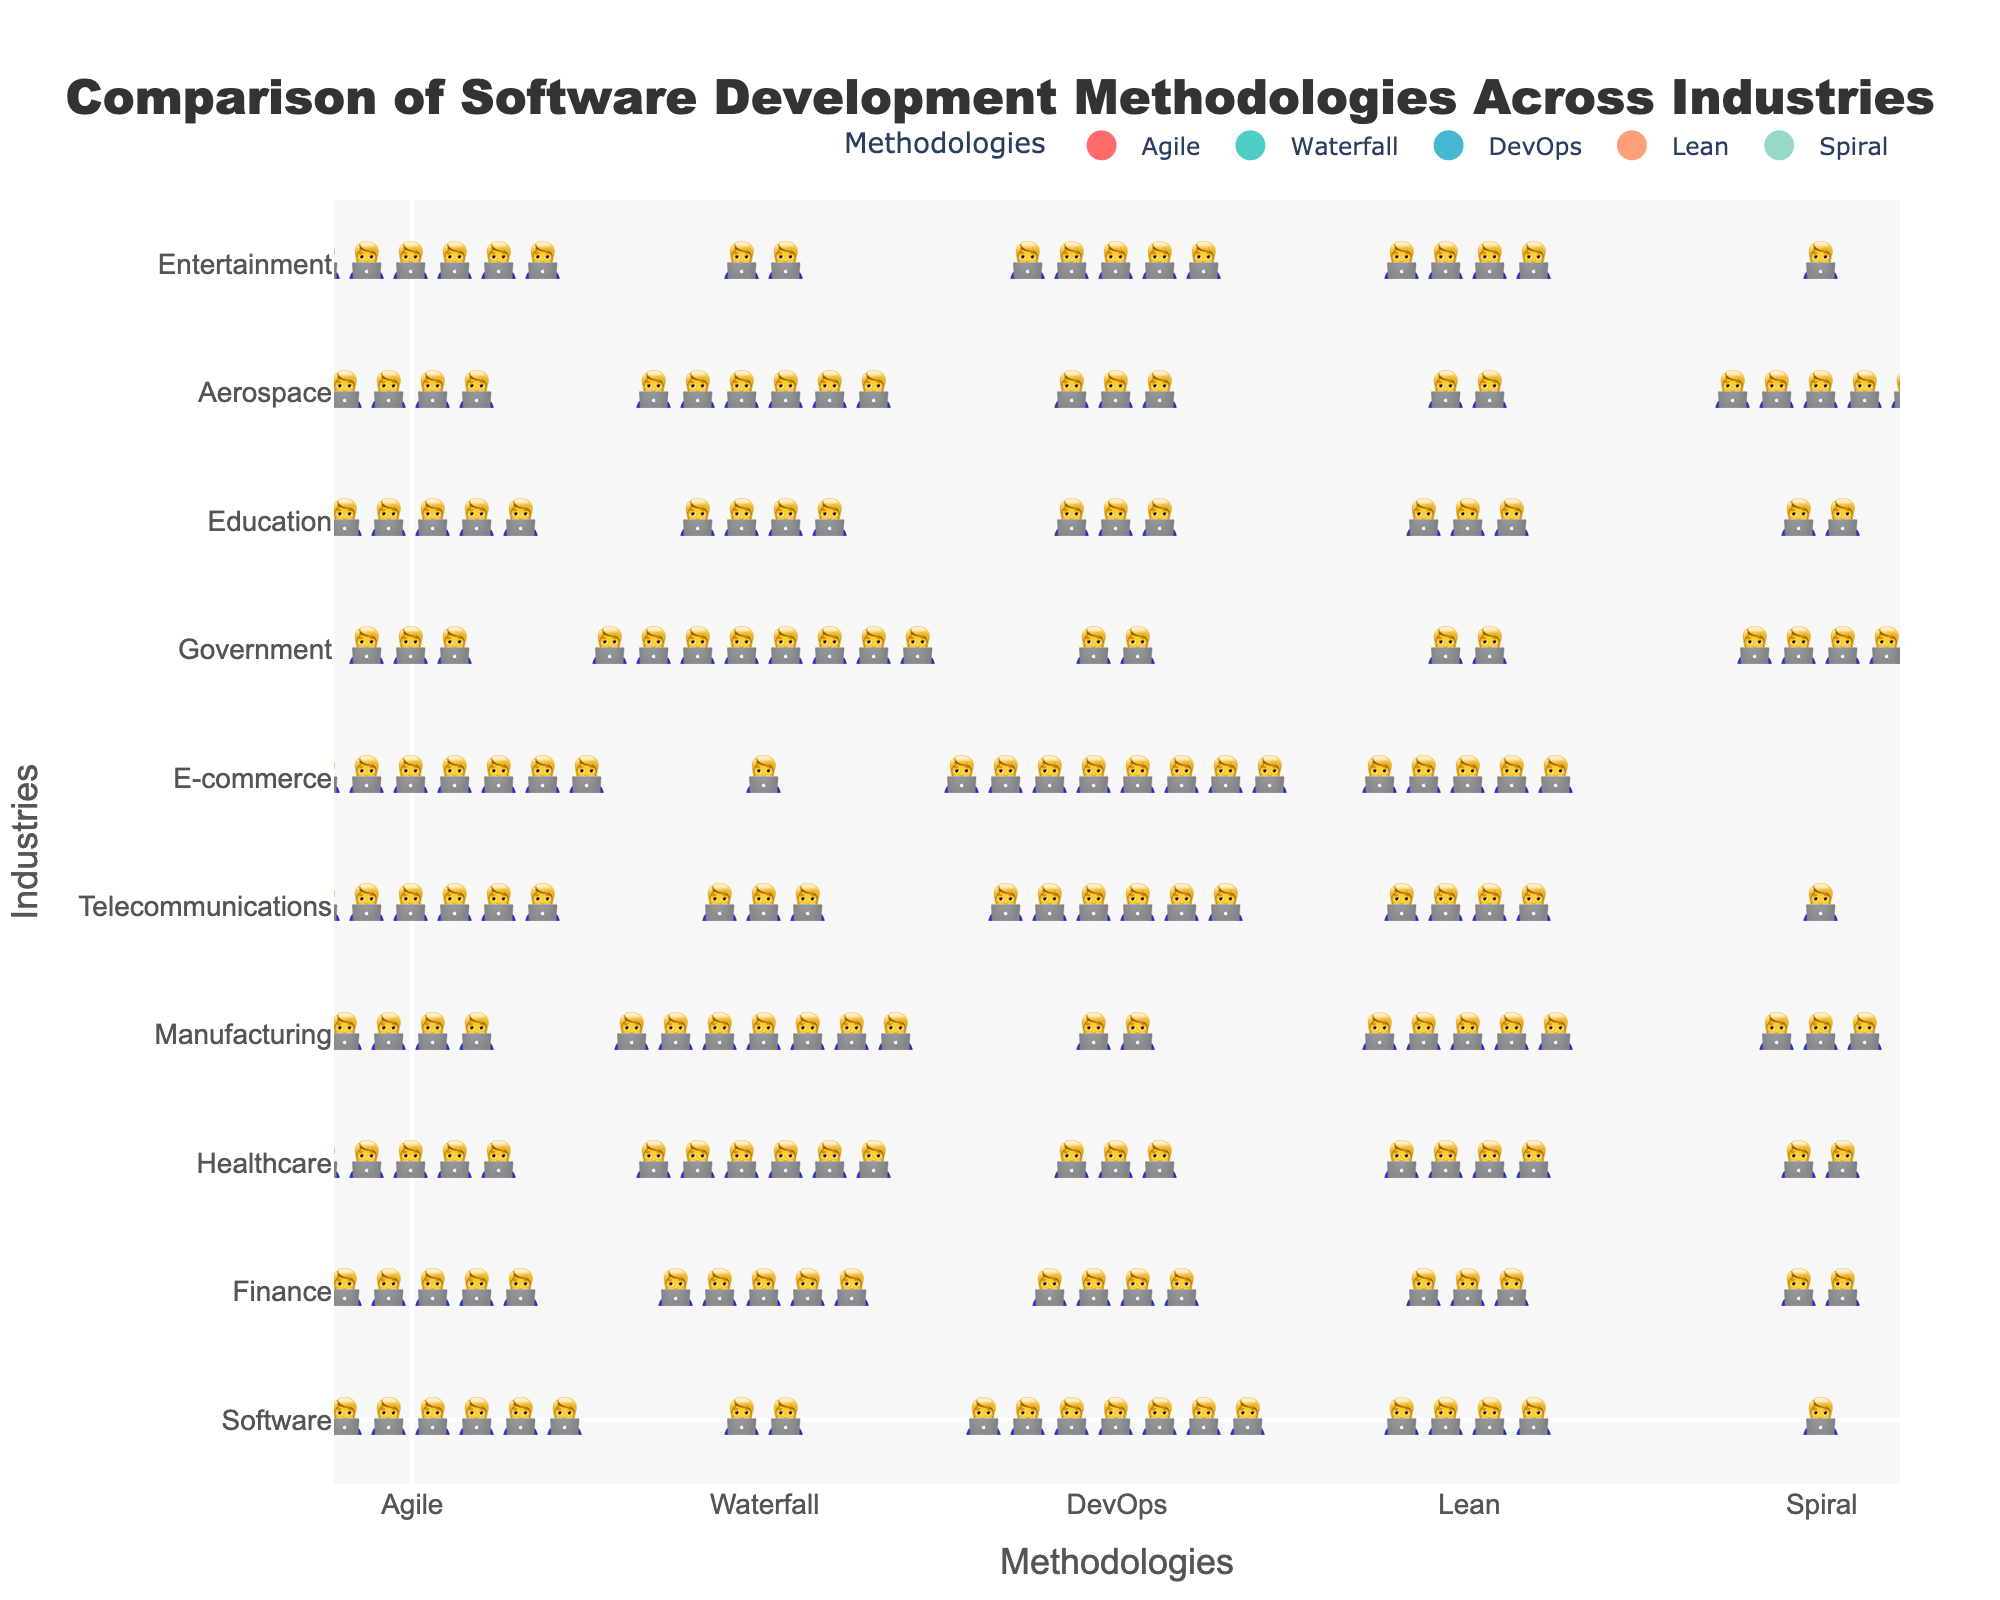Which industry uses Agile methodology the most? The industry with the highest number of icons representing Agile is E-commerce, with 9 icons.
Answer: E-commerce How many industries have more than 5 icons for the Waterfall methodology? Count the industries where the number of icons for Waterfall is greater than 5: Finance (5), Healthcare (6), Manufacturing (7), Government (8), and Aerospace (6).
Answer: 5 Which methodologies are used equally by the Telecommunications industry? For the Telecommunications industry, find the methodologies that have the same number of icons. Both Lean (4) and Waterfall (3) have the same number.
Answer: Lean and Waterfall What is the average number of icons for DevOps methodology across all industries? Add the number of icons for DevOps in each industry and divide by the total number of industries: (7+4+3+2+6+8+2+3+3+5) / 10 = 4.3
Answer: 4.3 Which industry uses the Spiral methodology the least? Find the industry with the lowest number of icons for Spiral, which is E-commerce with 0 icons.
Answer: E-commerce Between Healthcare and Finance, which industry uses the Lean methodology more? Compare the number of Lean icons for Healthcare (4) and Finance (3). Healthcare has more.
Answer: Healthcare How many total icons are there for the Agile methodology across all industries? Sum the number of Agile icons across all industries: 8+6+5+4+7+9+3+6+4+7 = 59
Answer: 59 Which industry uses the fewest number of methodologies (total number of icons)? Sum the total number of icons for each industry and find the one with the lowest sum. Government (3+8+2+2+4=19) has the fewest icons.
Answer: Government What is the difference in the number of Waterfall icons between Software and Government industries? Subtract the number of Waterfall icons in Government (8) from that in Software (2): 8 - 2 = 6
Answer: 6 Are there any industries with an equal number of icons for both DevOps and Spiral methodologies? Compare the number of DevOps and Spiral icons for each industry: Healthcare (3, 2), Aerospace (3, 5), and others do not match. There is none.
Answer: No 